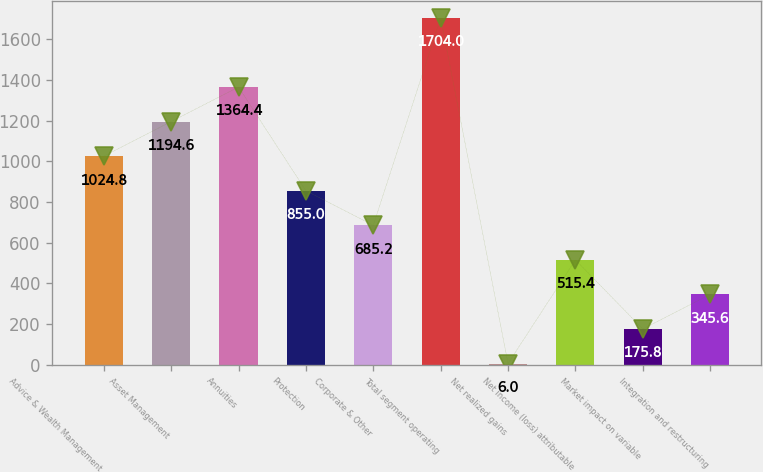<chart> <loc_0><loc_0><loc_500><loc_500><bar_chart><fcel>Advice & Wealth Management<fcel>Asset Management<fcel>Annuities<fcel>Protection<fcel>Corporate & Other<fcel>Total segment operating<fcel>Net realized gains<fcel>Net income (loss) attributable<fcel>Market impact on variable<fcel>Integration and restructuring<nl><fcel>1024.8<fcel>1194.6<fcel>1364.4<fcel>855<fcel>685.2<fcel>1704<fcel>6<fcel>515.4<fcel>175.8<fcel>345.6<nl></chart> 